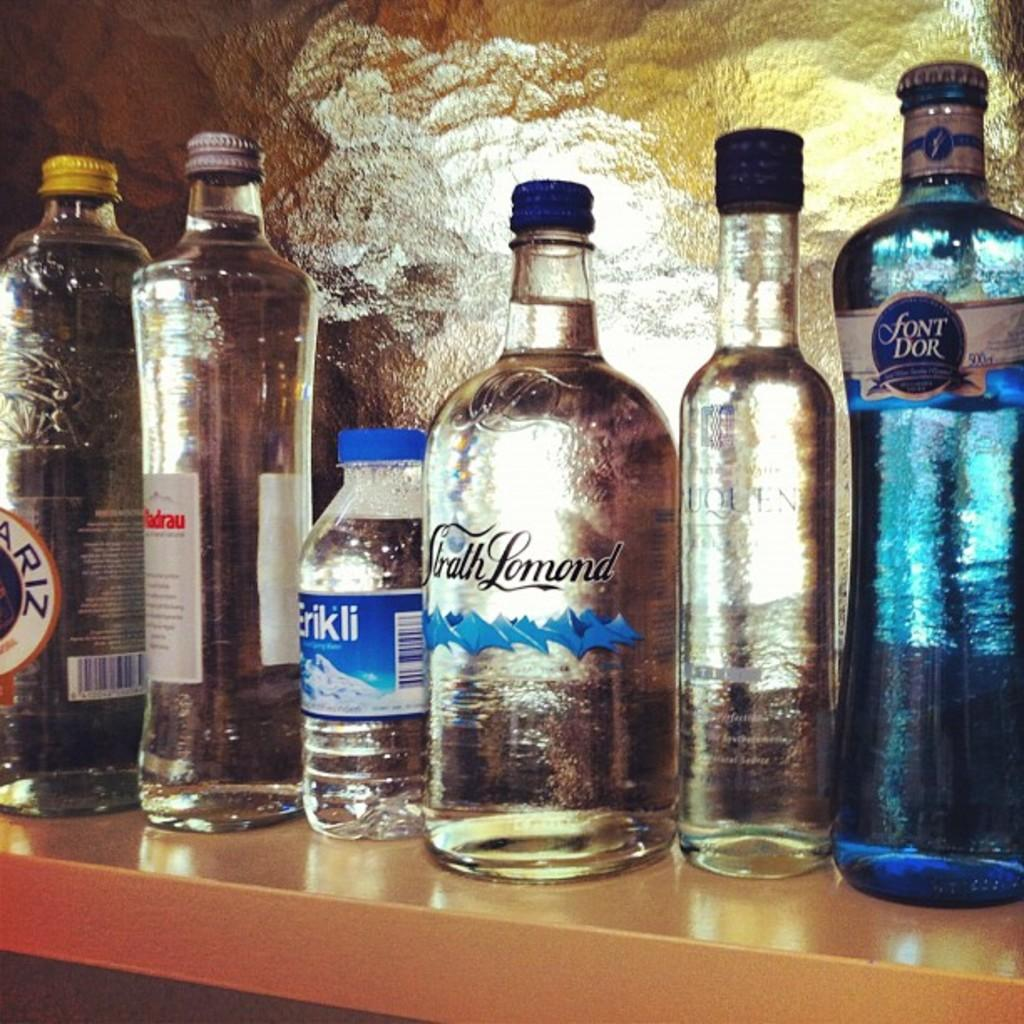Provide a one-sentence caption for the provided image. Several bottles, one of which is blue and is called font dor. 